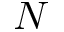<formula> <loc_0><loc_0><loc_500><loc_500>N</formula> 